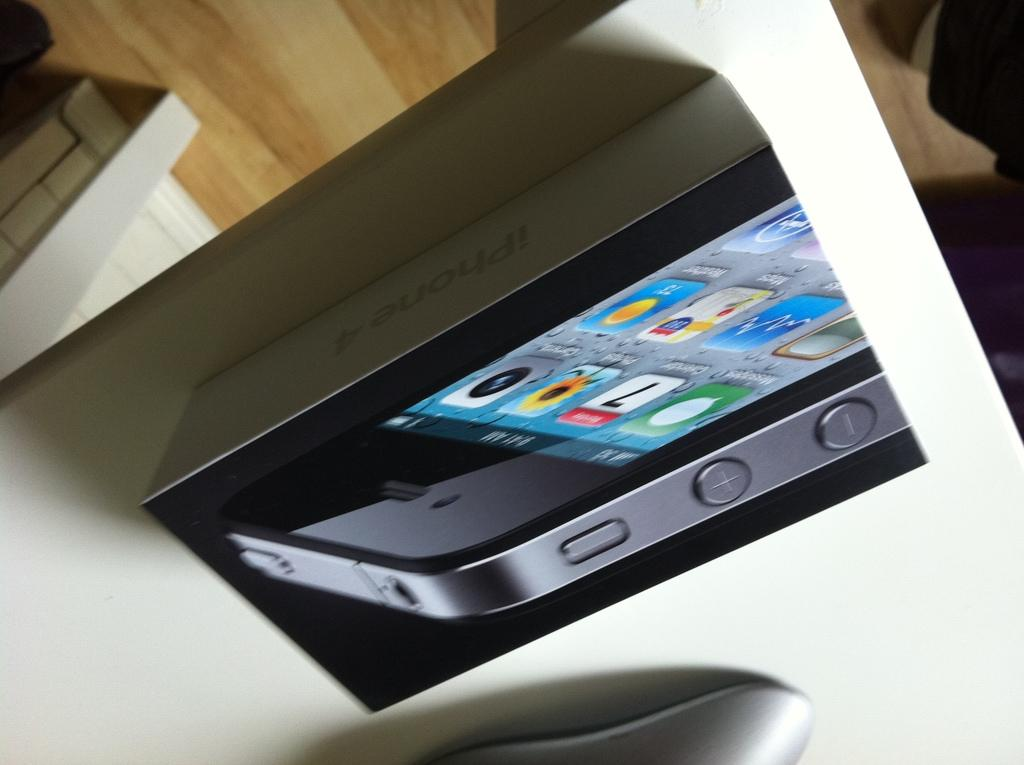<image>
Present a compact description of the photo's key features. an iphone 4 displayed coming out of its box 